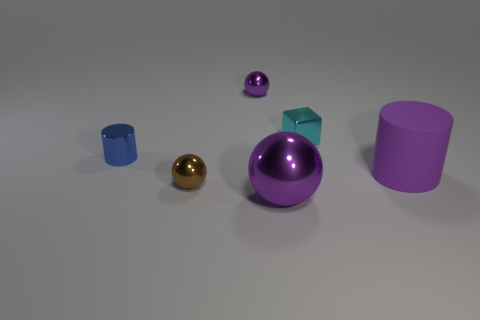Is there anything else that is the same size as the block?
Offer a very short reply. Yes. Is there anything else that is the same material as the large cylinder?
Offer a very short reply. No. How many other tiny things are the same color as the matte thing?
Make the answer very short. 1. There is a purple metallic object behind the purple rubber cylinder; is its shape the same as the small brown object?
Your response must be concise. Yes. How many objects are things that are to the left of the purple rubber object or things on the left side of the cyan cube?
Make the answer very short. 5. There is another big object that is the same shape as the blue metallic object; what is its color?
Provide a succinct answer. Purple. Are there any other things that are the same shape as the cyan object?
Offer a very short reply. No. Does the large purple matte thing have the same shape as the blue object that is to the left of the purple matte thing?
Provide a short and direct response. Yes. What is the purple cylinder made of?
Provide a succinct answer. Rubber. The other purple metal thing that is the same shape as the small purple object is what size?
Provide a succinct answer. Large. 